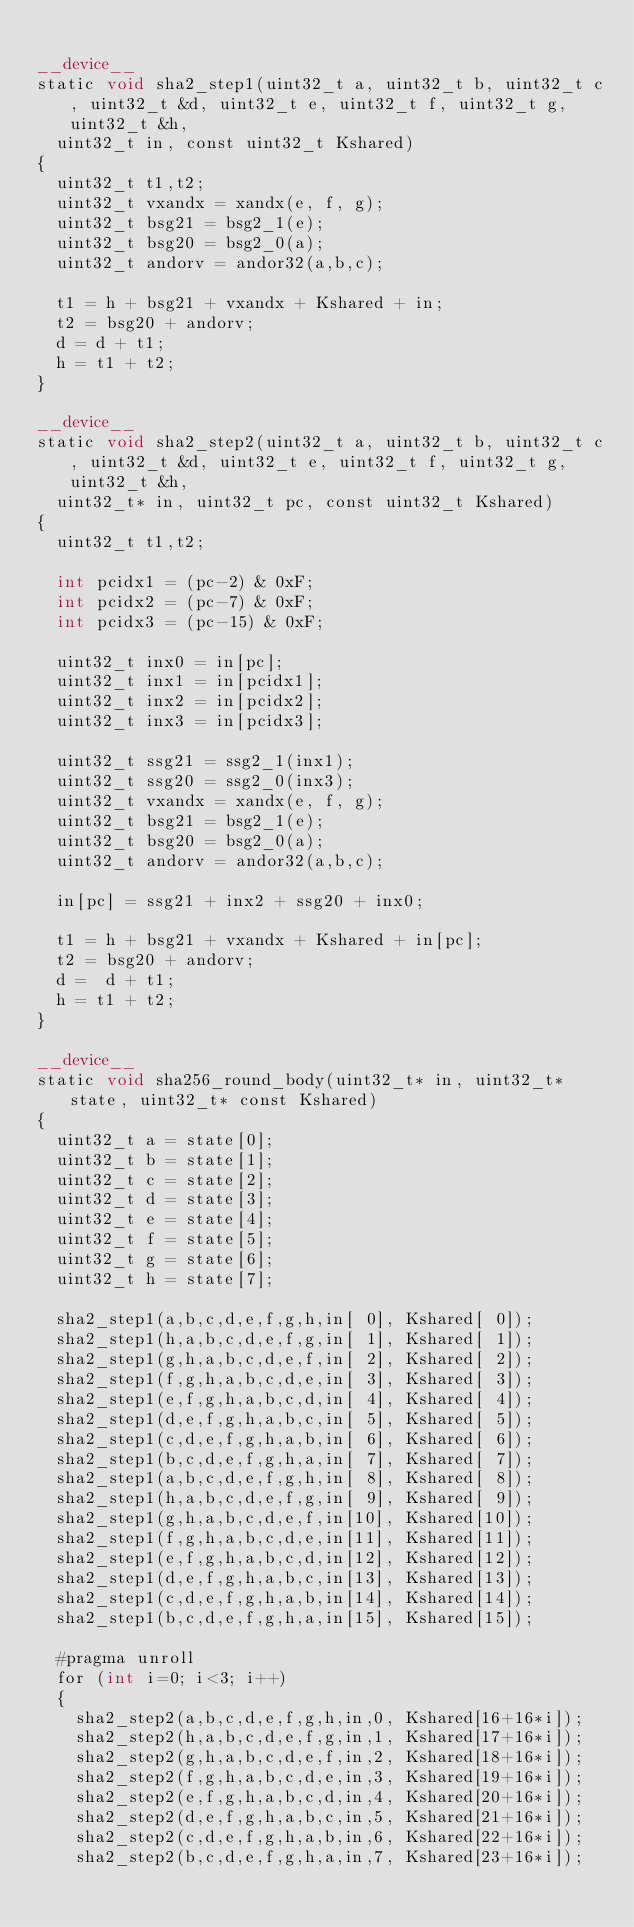<code> <loc_0><loc_0><loc_500><loc_500><_Cuda_>
__device__
static void sha2_step1(uint32_t a, uint32_t b, uint32_t c, uint32_t &d, uint32_t e, uint32_t f, uint32_t g, uint32_t &h,
	uint32_t in, const uint32_t Kshared)
{
	uint32_t t1,t2;
	uint32_t vxandx = xandx(e, f, g);
	uint32_t bsg21 = bsg2_1(e);
	uint32_t bsg20 = bsg2_0(a);
	uint32_t andorv = andor32(a,b,c);

	t1 = h + bsg21 + vxandx + Kshared + in;
	t2 = bsg20 + andorv;
	d = d + t1;
	h = t1 + t2;
}

__device__
static void sha2_step2(uint32_t a, uint32_t b, uint32_t c, uint32_t &d, uint32_t e, uint32_t f, uint32_t g, uint32_t &h,
	uint32_t* in, uint32_t pc, const uint32_t Kshared)
{
	uint32_t t1,t2;

	int pcidx1 = (pc-2) & 0xF;
	int pcidx2 = (pc-7) & 0xF;
	int pcidx3 = (pc-15) & 0xF;

	uint32_t inx0 = in[pc];
	uint32_t inx1 = in[pcidx1];
	uint32_t inx2 = in[pcidx2];
	uint32_t inx3 = in[pcidx3];

	uint32_t ssg21 = ssg2_1(inx1);
	uint32_t ssg20 = ssg2_0(inx3);
	uint32_t vxandx = xandx(e, f, g);
	uint32_t bsg21 = bsg2_1(e);
	uint32_t bsg20 = bsg2_0(a);
	uint32_t andorv = andor32(a,b,c);

	in[pc] = ssg21 + inx2 + ssg20 + inx0;

	t1 = h + bsg21 + vxandx + Kshared + in[pc];
	t2 = bsg20 + andorv;
	d =  d + t1;
	h = t1 + t2;
}

__device__
static void sha256_round_body(uint32_t* in, uint32_t* state, uint32_t* const Kshared)
{
	uint32_t a = state[0];
	uint32_t b = state[1];
	uint32_t c = state[2];
	uint32_t d = state[3];
	uint32_t e = state[4];
	uint32_t f = state[5];
	uint32_t g = state[6];
	uint32_t h = state[7];

	sha2_step1(a,b,c,d,e,f,g,h,in[ 0], Kshared[ 0]);
	sha2_step1(h,a,b,c,d,e,f,g,in[ 1], Kshared[ 1]);
	sha2_step1(g,h,a,b,c,d,e,f,in[ 2], Kshared[ 2]);
	sha2_step1(f,g,h,a,b,c,d,e,in[ 3], Kshared[ 3]);
	sha2_step1(e,f,g,h,a,b,c,d,in[ 4], Kshared[ 4]);
	sha2_step1(d,e,f,g,h,a,b,c,in[ 5], Kshared[ 5]);
	sha2_step1(c,d,e,f,g,h,a,b,in[ 6], Kshared[ 6]);
	sha2_step1(b,c,d,e,f,g,h,a,in[ 7], Kshared[ 7]);
	sha2_step1(a,b,c,d,e,f,g,h,in[ 8], Kshared[ 8]);
	sha2_step1(h,a,b,c,d,e,f,g,in[ 9], Kshared[ 9]);
	sha2_step1(g,h,a,b,c,d,e,f,in[10], Kshared[10]);
	sha2_step1(f,g,h,a,b,c,d,e,in[11], Kshared[11]);
	sha2_step1(e,f,g,h,a,b,c,d,in[12], Kshared[12]);
	sha2_step1(d,e,f,g,h,a,b,c,in[13], Kshared[13]);
	sha2_step1(c,d,e,f,g,h,a,b,in[14], Kshared[14]);
	sha2_step1(b,c,d,e,f,g,h,a,in[15], Kshared[15]);

	#pragma unroll
	for (int i=0; i<3; i++)
	{
		sha2_step2(a,b,c,d,e,f,g,h,in,0, Kshared[16+16*i]);
		sha2_step2(h,a,b,c,d,e,f,g,in,1, Kshared[17+16*i]);
		sha2_step2(g,h,a,b,c,d,e,f,in,2, Kshared[18+16*i]);
		sha2_step2(f,g,h,a,b,c,d,e,in,3, Kshared[19+16*i]);
		sha2_step2(e,f,g,h,a,b,c,d,in,4, Kshared[20+16*i]);
		sha2_step2(d,e,f,g,h,a,b,c,in,5, Kshared[21+16*i]);
		sha2_step2(c,d,e,f,g,h,a,b,in,6, Kshared[22+16*i]);
		sha2_step2(b,c,d,e,f,g,h,a,in,7, Kshared[23+16*i]);</code> 